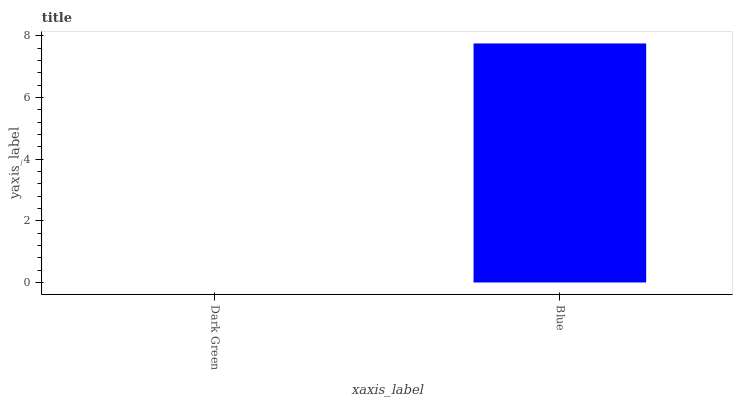Is Blue the minimum?
Answer yes or no. No. Is Blue greater than Dark Green?
Answer yes or no. Yes. Is Dark Green less than Blue?
Answer yes or no. Yes. Is Dark Green greater than Blue?
Answer yes or no. No. Is Blue less than Dark Green?
Answer yes or no. No. Is Blue the high median?
Answer yes or no. Yes. Is Dark Green the low median?
Answer yes or no. Yes. Is Dark Green the high median?
Answer yes or no. No. Is Blue the low median?
Answer yes or no. No. 